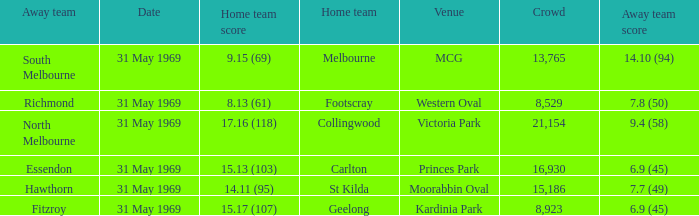Which home team scored 14.11 (95)? St Kilda. 